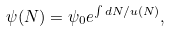Convert formula to latex. <formula><loc_0><loc_0><loc_500><loc_500>\psi ( N ) = \psi _ { 0 } e ^ { \int d N / u ( N ) } ,</formula> 